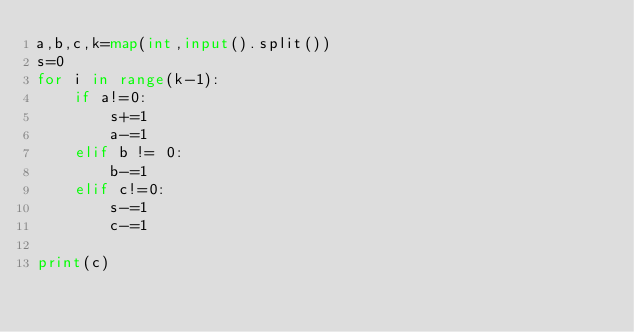<code> <loc_0><loc_0><loc_500><loc_500><_Python_>a,b,c,k=map(int,input().split())
s=0
for i in range(k-1):
    if a!=0:
        s+=1
        a-=1
    elif b != 0:
        b-=1
    elif c!=0:
        s-=1
        c-=1

print(c)
        
</code> 